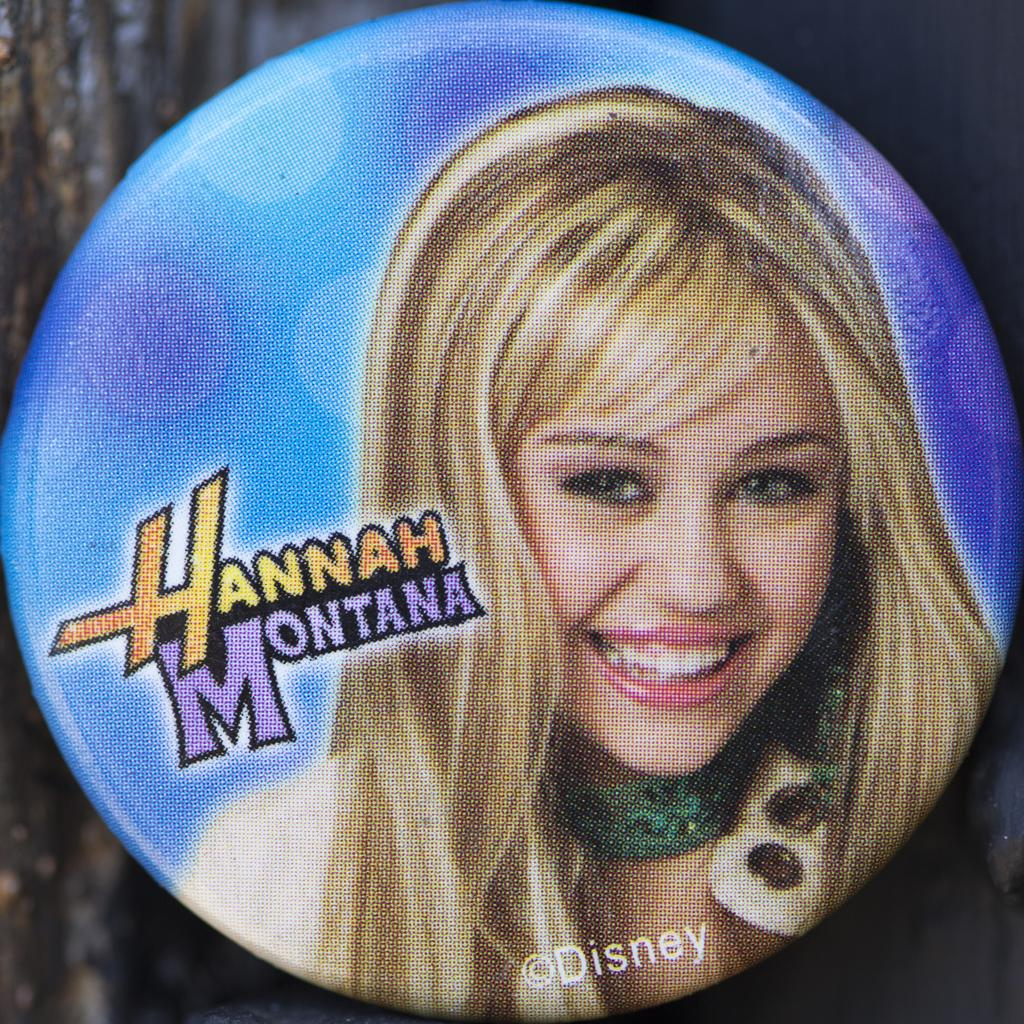What object is present in the image that features a photograph? There is a badge in the image that features a photograph. Can you describe the photograph on the badge? The photograph on the badge is of Hannah Montana. How does the badge kick the soccer ball in the image? The badge does not kick a soccer ball in the image; it is an inanimate object with a photograph of Hannah Montana. 